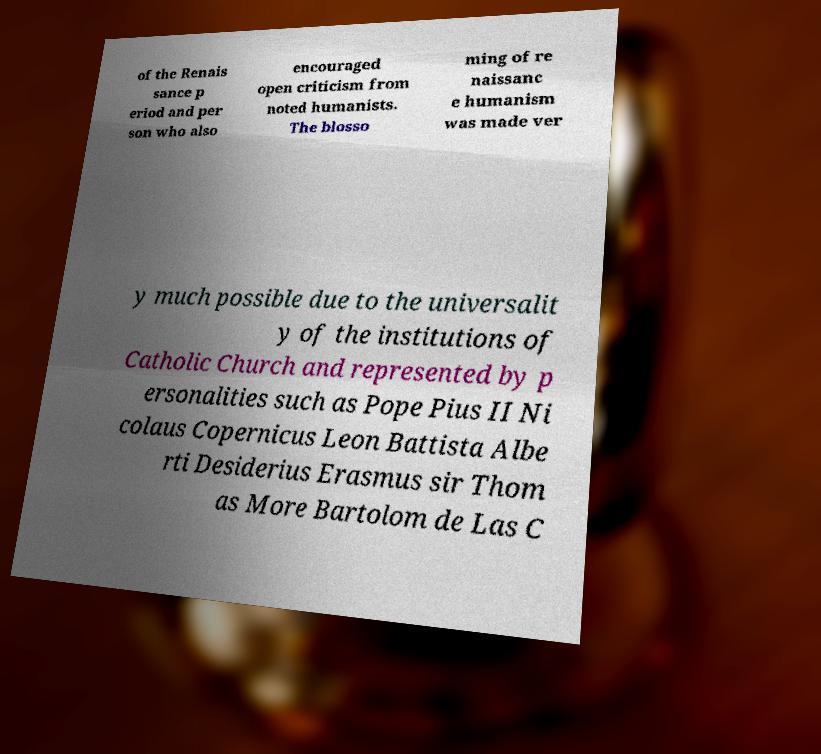Please identify and transcribe the text found in this image. of the Renais sance p eriod and per son who also encouraged open criticism from noted humanists. The blosso ming of re naissanc e humanism was made ver y much possible due to the universalit y of the institutions of Catholic Church and represented by p ersonalities such as Pope Pius II Ni colaus Copernicus Leon Battista Albe rti Desiderius Erasmus sir Thom as More Bartolom de Las C 